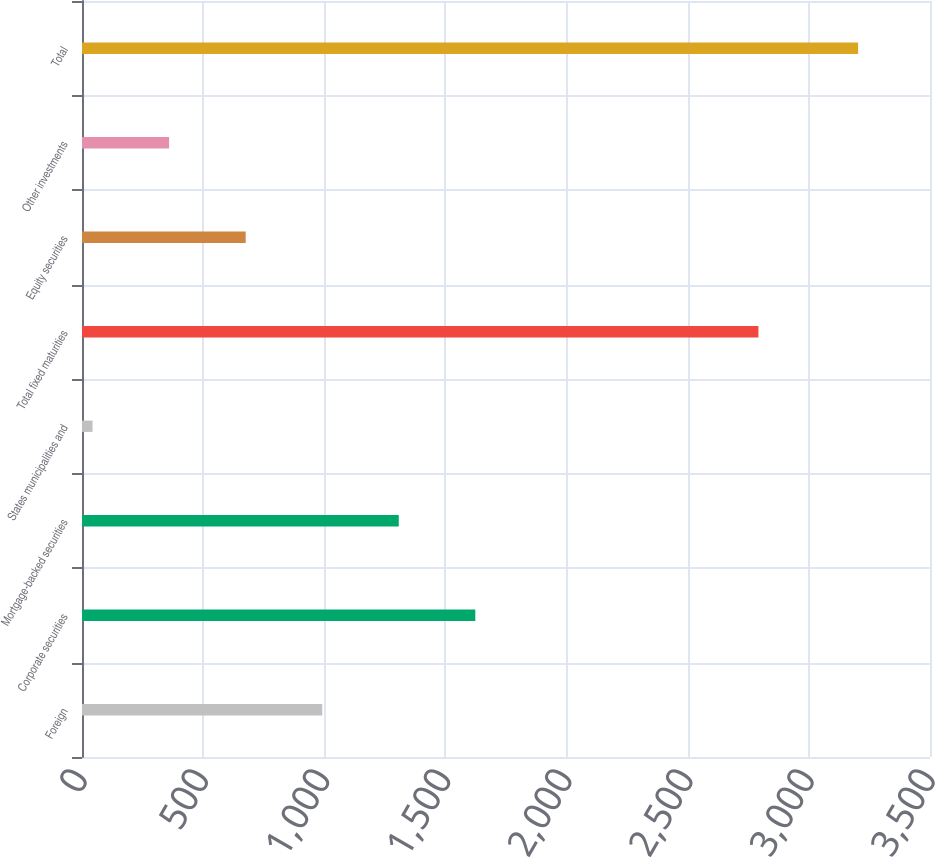Convert chart to OTSL. <chart><loc_0><loc_0><loc_500><loc_500><bar_chart><fcel>Foreign<fcel>Corporate securities<fcel>Mortgage-backed securities<fcel>States municipalities and<fcel>Total fixed maturities<fcel>Equity securities<fcel>Other investments<fcel>Total<nl><fcel>991.48<fcel>1623.4<fcel>1307.44<fcel>43.6<fcel>2791.8<fcel>675.52<fcel>359.56<fcel>3203.2<nl></chart> 